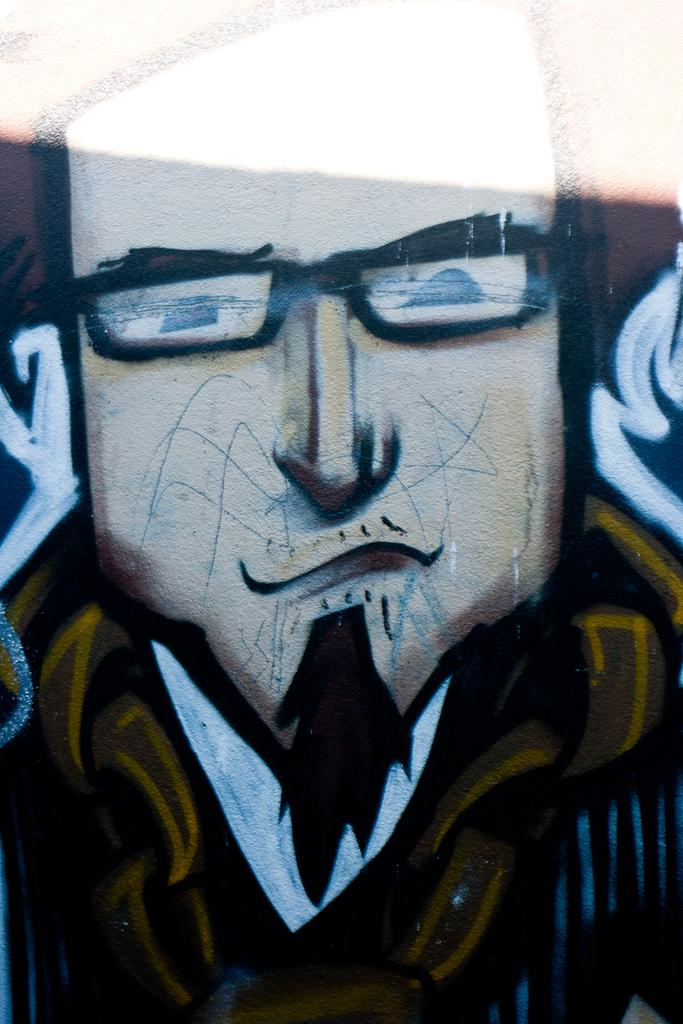What is depicted in the image? There is a painting in the image. What is the subject of the painting? The painting is of a person. Where is the painting located? The painting is on a wall. How many pigs can be seen walking in the painting? There are no pigs present in the painting, nor are there any people walking in the image. 